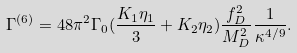<formula> <loc_0><loc_0><loc_500><loc_500>\Gamma ^ { ( 6 ) } = 4 8 \pi ^ { 2 } \Gamma _ { 0 } ( \frac { K _ { 1 } \eta _ { 1 } } { 3 } + K _ { 2 } \eta _ { 2 } ) \frac { f _ { D } ^ { 2 } } { M ^ { 2 } _ { D } } \frac { 1 } { \kappa ^ { 4 / 9 } } .</formula> 